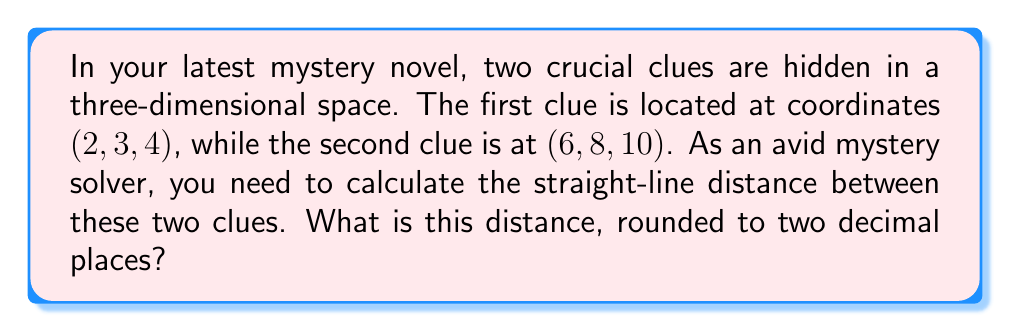Give your solution to this math problem. To solve this problem, we can use the three-dimensional distance formula, which is an extension of the Pythagorean theorem to 3D space. The formula is:

$$d = \sqrt{(x_2-x_1)^2 + (y_2-y_1)^2 + (z_2-z_1)^2}$$

Where $(x_1, y_1, z_1)$ are the coordinates of the first point and $(x_2, y_2, z_2)$ are the coordinates of the second point.

Let's plug in our values:
$(x_1, y_1, z_1) = (2, 3, 4)$
$(x_2, y_2, z_2) = (6, 8, 10)$

Now, let's calculate each part inside the square root:

$(x_2-x_1)^2 = (6-2)^2 = 4^2 = 16$
$(y_2-y_1)^2 = (8-3)^2 = 5^2 = 25$
$(z_2-z_1)^2 = (10-4)^2 = 6^2 = 36$

Adding these up:

$$d = \sqrt{16 + 25 + 36} = \sqrt{77}$$

Using a calculator to evaluate and round to two decimal places:

$$d \approx 8.77$$
Answer: 8.77 units 